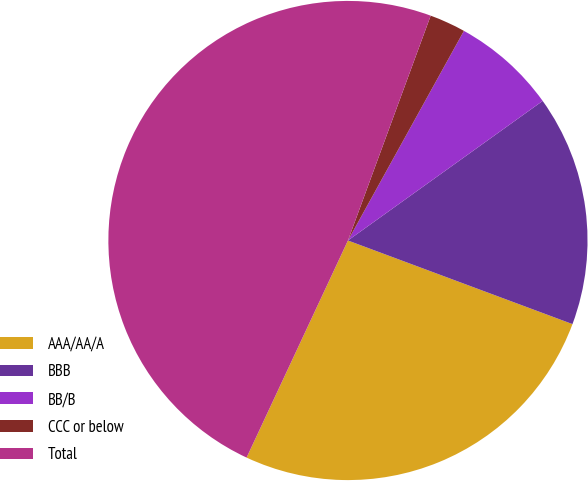Convert chart to OTSL. <chart><loc_0><loc_0><loc_500><loc_500><pie_chart><fcel>AAA/AA/A<fcel>BBB<fcel>BB/B<fcel>CCC or below<fcel>Total<nl><fcel>26.28%<fcel>15.57%<fcel>7.06%<fcel>2.43%<fcel>48.66%<nl></chart> 